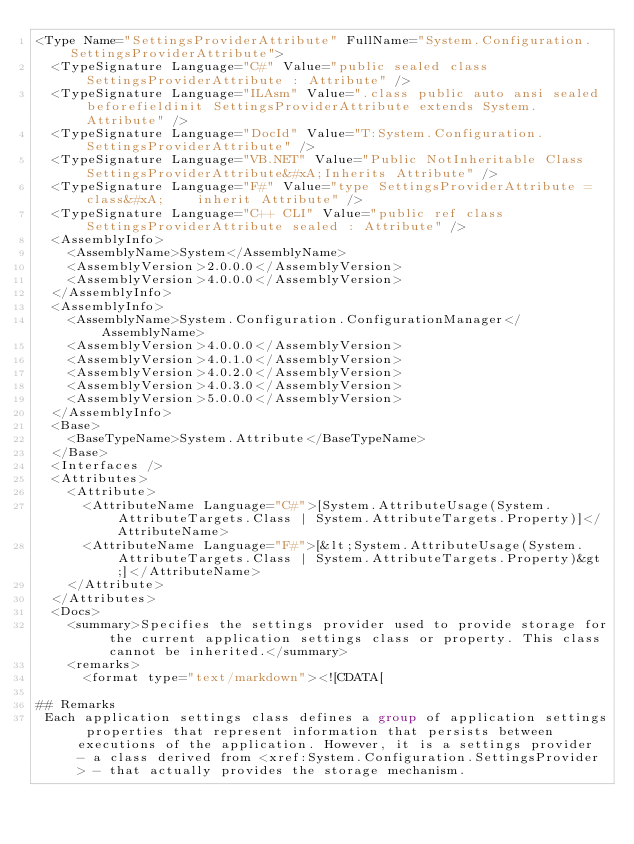<code> <loc_0><loc_0><loc_500><loc_500><_XML_><Type Name="SettingsProviderAttribute" FullName="System.Configuration.SettingsProviderAttribute">
  <TypeSignature Language="C#" Value="public sealed class SettingsProviderAttribute : Attribute" />
  <TypeSignature Language="ILAsm" Value=".class public auto ansi sealed beforefieldinit SettingsProviderAttribute extends System.Attribute" />
  <TypeSignature Language="DocId" Value="T:System.Configuration.SettingsProviderAttribute" />
  <TypeSignature Language="VB.NET" Value="Public NotInheritable Class SettingsProviderAttribute&#xA;Inherits Attribute" />
  <TypeSignature Language="F#" Value="type SettingsProviderAttribute = class&#xA;    inherit Attribute" />
  <TypeSignature Language="C++ CLI" Value="public ref class SettingsProviderAttribute sealed : Attribute" />
  <AssemblyInfo>
    <AssemblyName>System</AssemblyName>
    <AssemblyVersion>2.0.0.0</AssemblyVersion>
    <AssemblyVersion>4.0.0.0</AssemblyVersion>
  </AssemblyInfo>
  <AssemblyInfo>
    <AssemblyName>System.Configuration.ConfigurationManager</AssemblyName>
    <AssemblyVersion>4.0.0.0</AssemblyVersion>
    <AssemblyVersion>4.0.1.0</AssemblyVersion>
    <AssemblyVersion>4.0.2.0</AssemblyVersion>
    <AssemblyVersion>4.0.3.0</AssemblyVersion>
    <AssemblyVersion>5.0.0.0</AssemblyVersion>
  </AssemblyInfo>
  <Base>
    <BaseTypeName>System.Attribute</BaseTypeName>
  </Base>
  <Interfaces />
  <Attributes>
    <Attribute>
      <AttributeName Language="C#">[System.AttributeUsage(System.AttributeTargets.Class | System.AttributeTargets.Property)]</AttributeName>
      <AttributeName Language="F#">[&lt;System.AttributeUsage(System.AttributeTargets.Class | System.AttributeTargets.Property)&gt;]</AttributeName>
    </Attribute>
  </Attributes>
  <Docs>
    <summary>Specifies the settings provider used to provide storage for the current application settings class or property. This class cannot be inherited.</summary>
    <remarks>
      <format type="text/markdown"><![CDATA[  
  
## Remarks  
 Each application settings class defines a group of application settings properties that represent information that persists between executions of the application. However, it is a settings provider - a class derived from <xref:System.Configuration.SettingsProvider> - that actually provides the storage mechanism.  
  </code> 